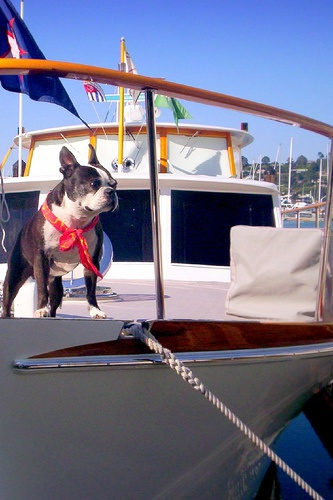Describe the objects in this image and their specific colors. I can see boat in gray, blue, lightgray, black, and darkgray tones and dog in blue, black, gray, and lightgray tones in this image. 